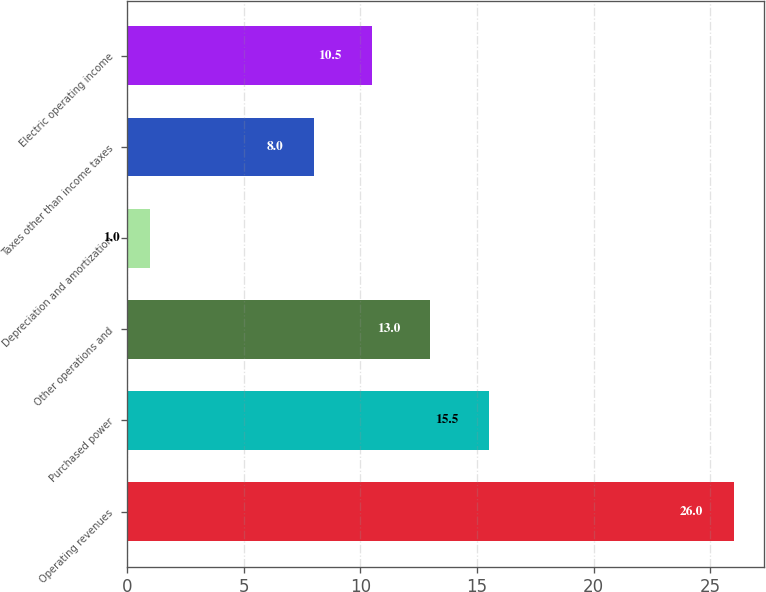Convert chart to OTSL. <chart><loc_0><loc_0><loc_500><loc_500><bar_chart><fcel>Operating revenues<fcel>Purchased power<fcel>Other operations and<fcel>Depreciation and amortization<fcel>Taxes other than income taxes<fcel>Electric operating income<nl><fcel>26<fcel>15.5<fcel>13<fcel>1<fcel>8<fcel>10.5<nl></chart> 